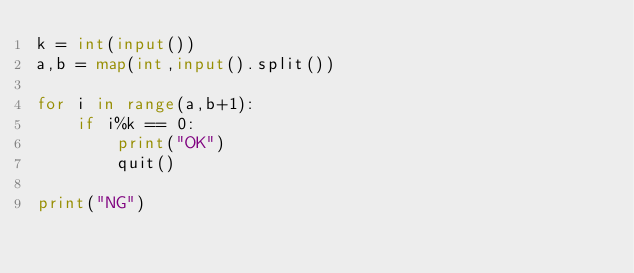<code> <loc_0><loc_0><loc_500><loc_500><_Python_>k = int(input())
a,b = map(int,input().split())

for i in range(a,b+1):
    if i%k == 0:
        print("OK")
        quit()

print("NG")</code> 